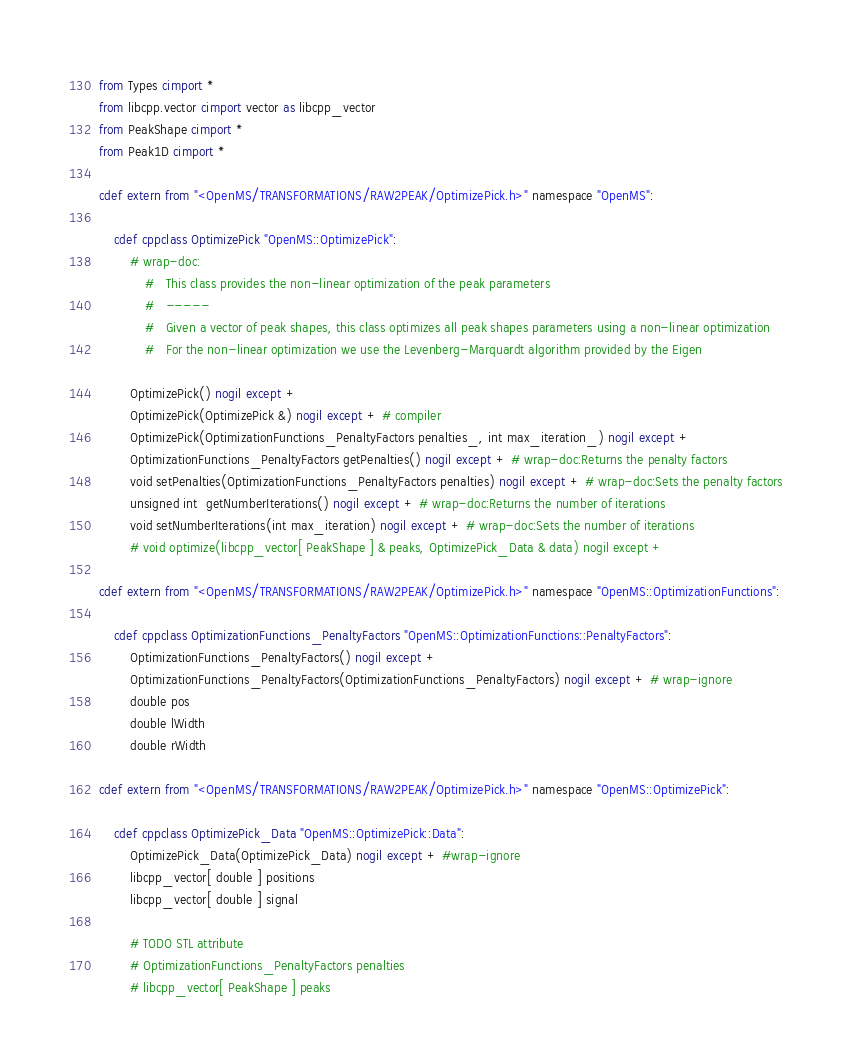<code> <loc_0><loc_0><loc_500><loc_500><_Cython_>from Types cimport *
from libcpp.vector cimport vector as libcpp_vector
from PeakShape cimport *
from Peak1D cimport *

cdef extern from "<OpenMS/TRANSFORMATIONS/RAW2PEAK/OptimizePick.h>" namespace "OpenMS":
    
    cdef cppclass OptimizePick "OpenMS::OptimizePick":
        # wrap-doc:
            #   This class provides the non-linear optimization of the peak parameters
            #   -----
            #   Given a vector of peak shapes, this class optimizes all peak shapes parameters using a non-linear optimization
            #   For the non-linear optimization we use the Levenberg-Marquardt algorithm provided by the Eigen

        OptimizePick() nogil except +
        OptimizePick(OptimizePick &) nogil except + # compiler
        OptimizePick(OptimizationFunctions_PenaltyFactors penalties_, int max_iteration_) nogil except +
        OptimizationFunctions_PenaltyFactors getPenalties() nogil except + # wrap-doc:Returns the penalty factors
        void setPenalties(OptimizationFunctions_PenaltyFactors penalties) nogil except + # wrap-doc:Sets the penalty factors
        unsigned int  getNumberIterations() nogil except + # wrap-doc:Returns the number of iterations
        void setNumberIterations(int max_iteration) nogil except + # wrap-doc:Sets the number of iterations
        # void optimize(libcpp_vector[ PeakShape ] & peaks, OptimizePick_Data & data) nogil except +

cdef extern from "<OpenMS/TRANSFORMATIONS/RAW2PEAK/OptimizePick.h>" namespace "OpenMS::OptimizationFunctions":
    
    cdef cppclass OptimizationFunctions_PenaltyFactors "OpenMS::OptimizationFunctions::PenaltyFactors":
        OptimizationFunctions_PenaltyFactors() nogil except +
        OptimizationFunctions_PenaltyFactors(OptimizationFunctions_PenaltyFactors) nogil except + # wrap-ignore
        double pos
        double lWidth
        double rWidth

cdef extern from "<OpenMS/TRANSFORMATIONS/RAW2PEAK/OptimizePick.h>" namespace "OpenMS::OptimizePick":
    
    cdef cppclass OptimizePick_Data "OpenMS::OptimizePick::Data":
        OptimizePick_Data(OptimizePick_Data) nogil except + #wrap-ignore
        libcpp_vector[ double ] positions
        libcpp_vector[ double ] signal

        # TODO STL attribute
        # OptimizationFunctions_PenaltyFactors penalties
        # libcpp_vector[ PeakShape ] peaks

</code> 